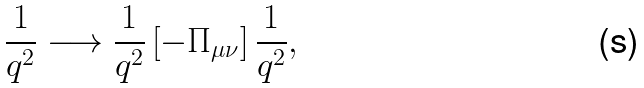Convert formula to latex. <formula><loc_0><loc_0><loc_500><loc_500>\frac { 1 } { q ^ { 2 } } \longrightarrow \frac { 1 } { q ^ { 2 } } \left [ - \Pi _ { \mu \nu } \right ] \frac { 1 } { q ^ { 2 } } ,</formula> 